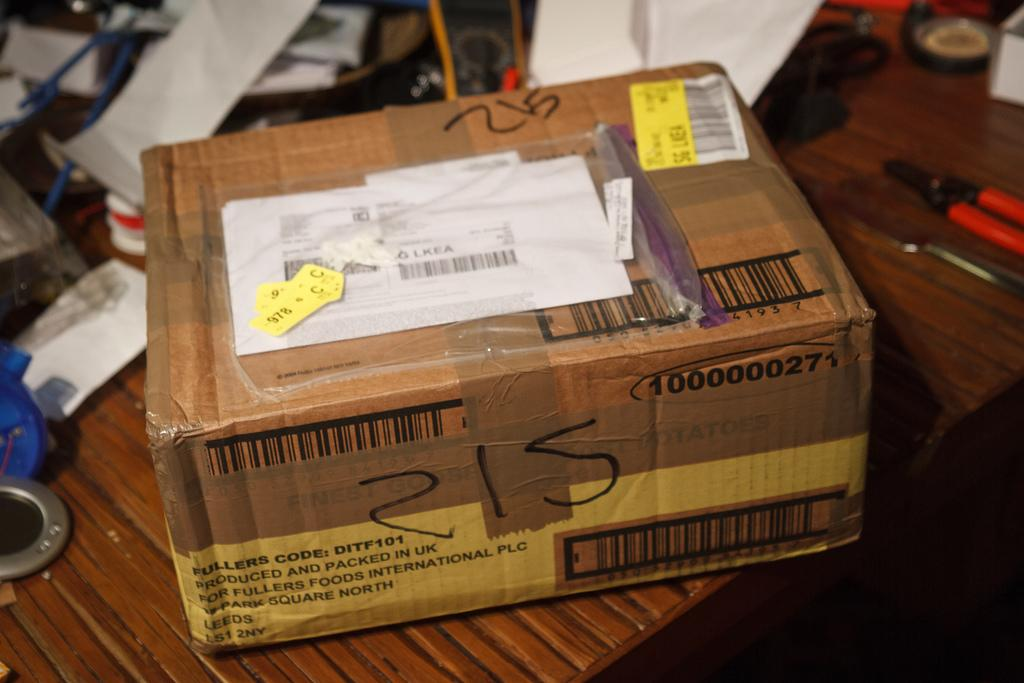<image>
Share a concise interpretation of the image provided. A wrapped package stating that is was produced and packed in the UK. 